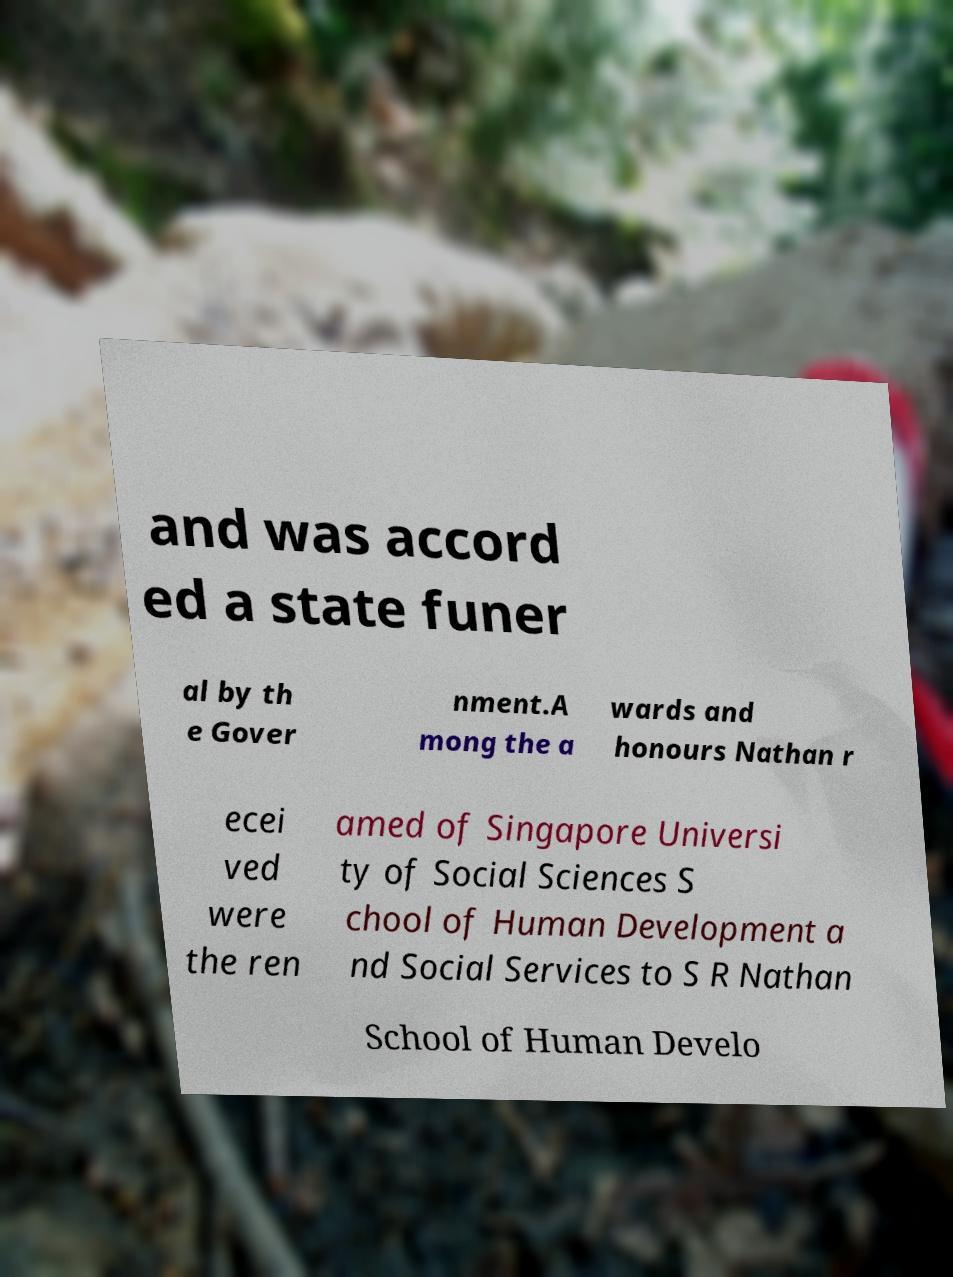What messages or text are displayed in this image? I need them in a readable, typed format. and was accord ed a state funer al by th e Gover nment.A mong the a wards and honours Nathan r ecei ved were the ren amed of Singapore Universi ty of Social Sciences S chool of Human Development a nd Social Services to S R Nathan School of Human Develo 